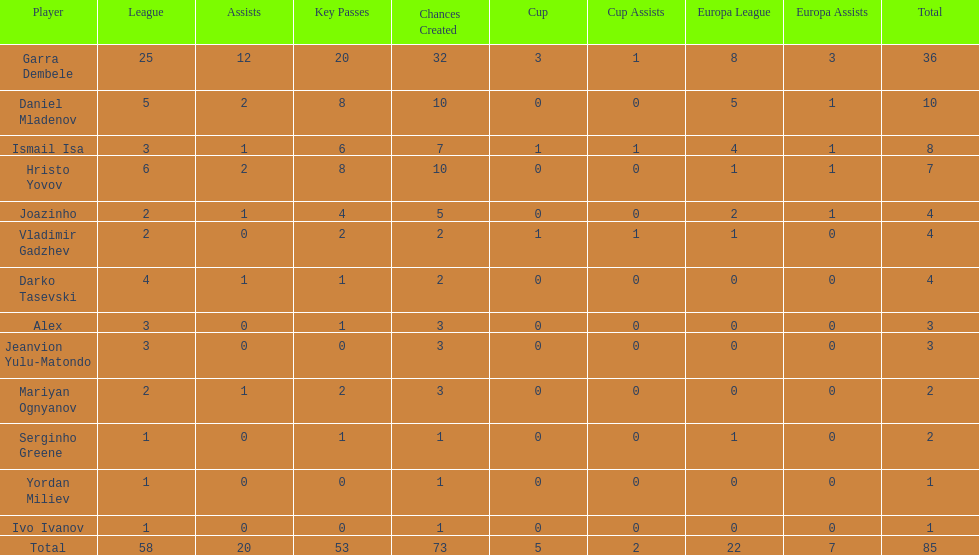Which sum is greater, the europa league total or the league total? League. 